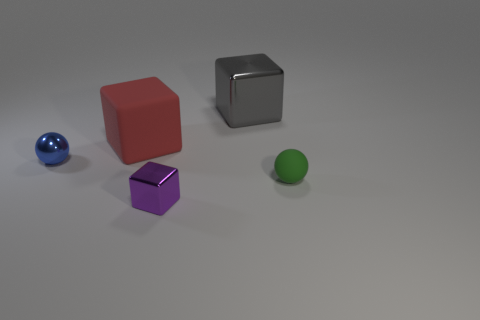Subtract all blue spheres. Subtract all purple cubes. How many spheres are left? 1 Add 3 purple objects. How many objects exist? 8 Subtract all blocks. How many objects are left? 2 Add 2 tiny purple metallic objects. How many tiny purple metallic objects are left? 3 Add 5 tiny objects. How many tiny objects exist? 8 Subtract 0 cyan cubes. How many objects are left? 5 Subtract all big cyan shiny things. Subtract all tiny blue shiny things. How many objects are left? 4 